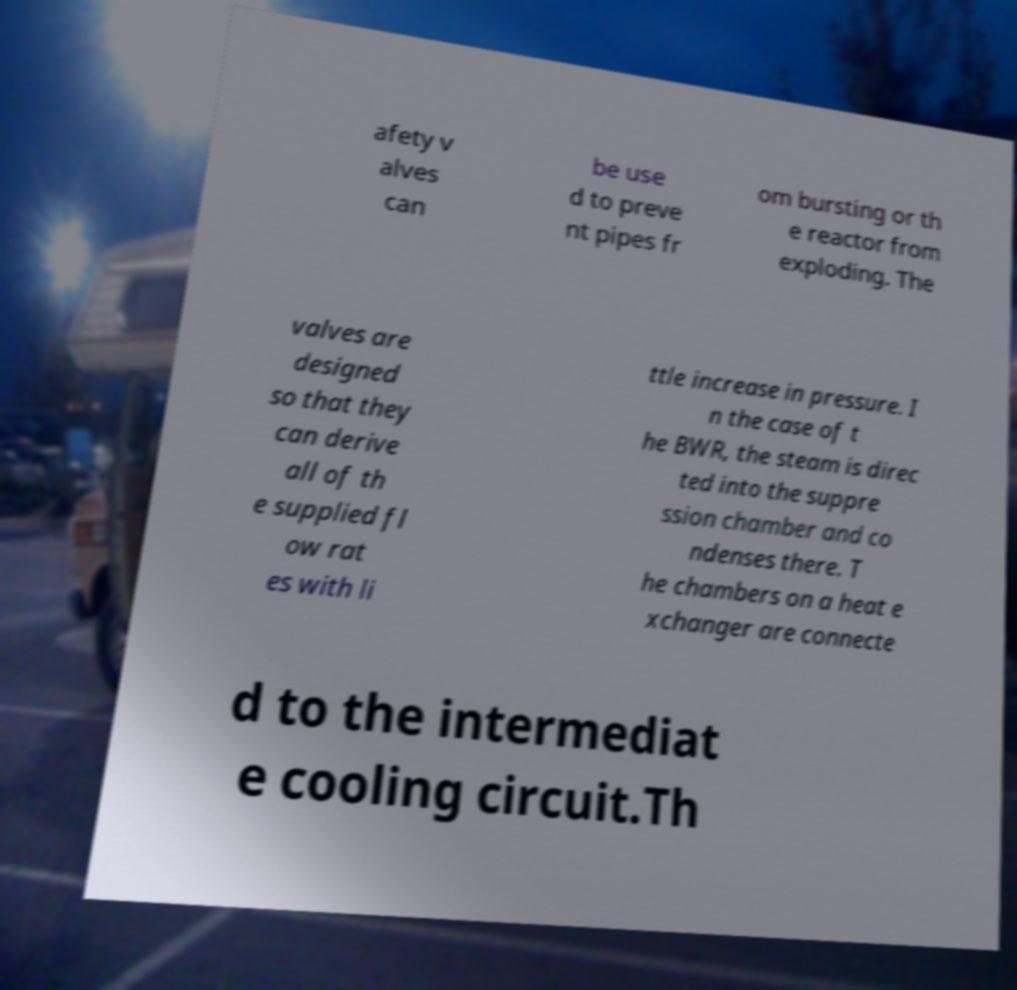I need the written content from this picture converted into text. Can you do that? afety v alves can be use d to preve nt pipes fr om bursting or th e reactor from exploding. The valves are designed so that they can derive all of th e supplied fl ow rat es with li ttle increase in pressure. I n the case of t he BWR, the steam is direc ted into the suppre ssion chamber and co ndenses there. T he chambers on a heat e xchanger are connecte d to the intermediat e cooling circuit.Th 